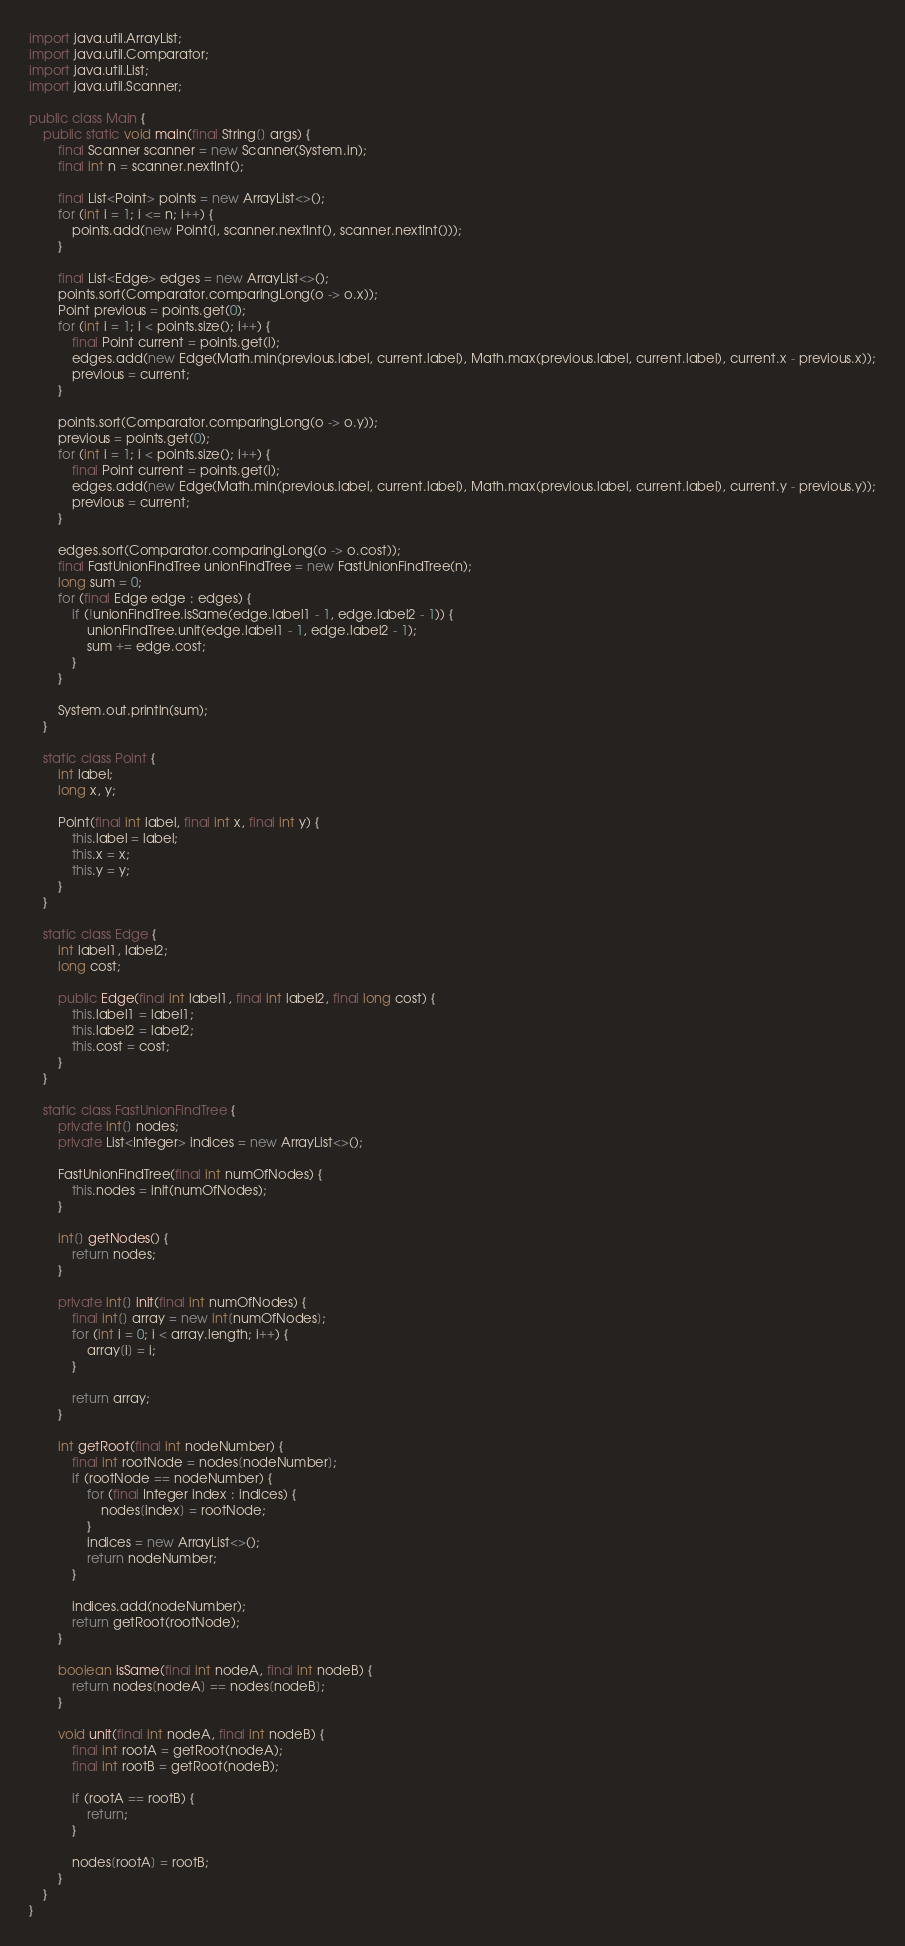<code> <loc_0><loc_0><loc_500><loc_500><_Java_>
import java.util.ArrayList;
import java.util.Comparator;
import java.util.List;
import java.util.Scanner;

public class Main {
    public static void main(final String[] args) {
        final Scanner scanner = new Scanner(System.in);
        final int n = scanner.nextInt();

        final List<Point> points = new ArrayList<>();
        for (int i = 1; i <= n; i++) {
            points.add(new Point(i, scanner.nextInt(), scanner.nextInt()));
        }

        final List<Edge> edges = new ArrayList<>();
        points.sort(Comparator.comparingLong(o -> o.x));
        Point previous = points.get(0);
        for (int i = 1; i < points.size(); i++) {
            final Point current = points.get(i);
            edges.add(new Edge(Math.min(previous.label, current.label), Math.max(previous.label, current.label), current.x - previous.x));
            previous = current;
        }

        points.sort(Comparator.comparingLong(o -> o.y));
        previous = points.get(0);
        for (int i = 1; i < points.size(); i++) {
            final Point current = points.get(i);
            edges.add(new Edge(Math.min(previous.label, current.label), Math.max(previous.label, current.label), current.y - previous.y));
            previous = current;
        }

        edges.sort(Comparator.comparingLong(o -> o.cost));
        final FastUnionFindTree unionFindTree = new FastUnionFindTree(n);
        long sum = 0;
        for (final Edge edge : edges) {
            if (!unionFindTree.isSame(edge.label1 - 1, edge.label2 - 1)) {
                unionFindTree.unit(edge.label1 - 1, edge.label2 - 1);
                sum += edge.cost;
            }
        }

        System.out.println(sum);
    }

    static class Point {
        int label;
        long x, y;

        Point(final int label, final int x, final int y) {
            this.label = label;
            this.x = x;
            this.y = y;
        }
    }

    static class Edge {
        int label1, label2;
        long cost;

        public Edge(final int label1, final int label2, final long cost) {
            this.label1 = label1;
            this.label2 = label2;
            this.cost = cost;
        }
    }

    static class FastUnionFindTree {
        private int[] nodes;
        private List<Integer> indices = new ArrayList<>();

        FastUnionFindTree(final int numOfNodes) {
            this.nodes = init(numOfNodes);
        }

        int[] getNodes() {
            return nodes;
        }

        private int[] init(final int numOfNodes) {
            final int[] array = new int[numOfNodes];
            for (int i = 0; i < array.length; i++) {
                array[i] = i;
            }

            return array;
        }

        int getRoot(final int nodeNumber) {
            final int rootNode = nodes[nodeNumber];
            if (rootNode == nodeNumber) {
                for (final Integer index : indices) {
                    nodes[index] = rootNode;
                }
                indices = new ArrayList<>();
                return nodeNumber;
            }

            indices.add(nodeNumber);
            return getRoot(rootNode);
        }

        boolean isSame(final int nodeA, final int nodeB) {
            return nodes[nodeA] == nodes[nodeB];
        }

        void unit(final int nodeA, final int nodeB) {
            final int rootA = getRoot(nodeA);
            final int rootB = getRoot(nodeB);

            if (rootA == rootB) {
                return;
            }

            nodes[rootA] = rootB;
        }
    }
}
</code> 